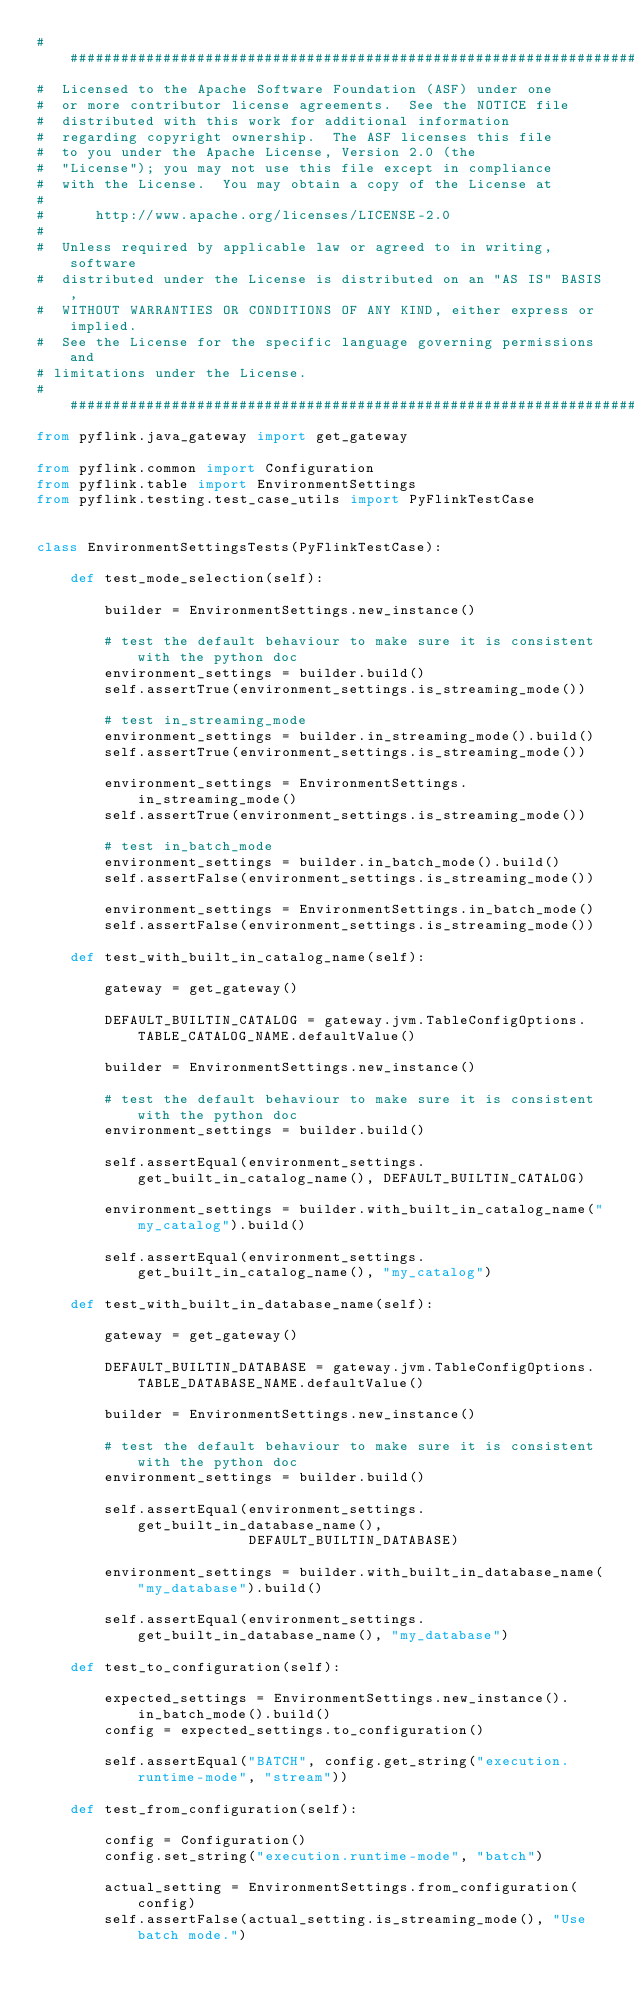<code> <loc_0><loc_0><loc_500><loc_500><_Python_>################################################################################
#  Licensed to the Apache Software Foundation (ASF) under one
#  or more contributor license agreements.  See the NOTICE file
#  distributed with this work for additional information
#  regarding copyright ownership.  The ASF licenses this file
#  to you under the Apache License, Version 2.0 (the
#  "License"); you may not use this file except in compliance
#  with the License.  You may obtain a copy of the License at
#
#      http://www.apache.org/licenses/LICENSE-2.0
#
#  Unless required by applicable law or agreed to in writing, software
#  distributed under the License is distributed on an "AS IS" BASIS,
#  WITHOUT WARRANTIES OR CONDITIONS OF ANY KIND, either express or implied.
#  See the License for the specific language governing permissions and
# limitations under the License.
################################################################################
from pyflink.java_gateway import get_gateway

from pyflink.common import Configuration
from pyflink.table import EnvironmentSettings
from pyflink.testing.test_case_utils import PyFlinkTestCase


class EnvironmentSettingsTests(PyFlinkTestCase):

    def test_mode_selection(self):

        builder = EnvironmentSettings.new_instance()

        # test the default behaviour to make sure it is consistent with the python doc
        environment_settings = builder.build()
        self.assertTrue(environment_settings.is_streaming_mode())

        # test in_streaming_mode
        environment_settings = builder.in_streaming_mode().build()
        self.assertTrue(environment_settings.is_streaming_mode())

        environment_settings = EnvironmentSettings.in_streaming_mode()
        self.assertTrue(environment_settings.is_streaming_mode())

        # test in_batch_mode
        environment_settings = builder.in_batch_mode().build()
        self.assertFalse(environment_settings.is_streaming_mode())

        environment_settings = EnvironmentSettings.in_batch_mode()
        self.assertFalse(environment_settings.is_streaming_mode())

    def test_with_built_in_catalog_name(self):

        gateway = get_gateway()

        DEFAULT_BUILTIN_CATALOG = gateway.jvm.TableConfigOptions.TABLE_CATALOG_NAME.defaultValue()

        builder = EnvironmentSettings.new_instance()

        # test the default behaviour to make sure it is consistent with the python doc
        environment_settings = builder.build()

        self.assertEqual(environment_settings.get_built_in_catalog_name(), DEFAULT_BUILTIN_CATALOG)

        environment_settings = builder.with_built_in_catalog_name("my_catalog").build()

        self.assertEqual(environment_settings.get_built_in_catalog_name(), "my_catalog")

    def test_with_built_in_database_name(self):

        gateway = get_gateway()

        DEFAULT_BUILTIN_DATABASE = gateway.jvm.TableConfigOptions.TABLE_DATABASE_NAME.defaultValue()

        builder = EnvironmentSettings.new_instance()

        # test the default behaviour to make sure it is consistent with the python doc
        environment_settings = builder.build()

        self.assertEqual(environment_settings.get_built_in_database_name(),
                         DEFAULT_BUILTIN_DATABASE)

        environment_settings = builder.with_built_in_database_name("my_database").build()

        self.assertEqual(environment_settings.get_built_in_database_name(), "my_database")

    def test_to_configuration(self):

        expected_settings = EnvironmentSettings.new_instance().in_batch_mode().build()
        config = expected_settings.to_configuration()

        self.assertEqual("BATCH", config.get_string("execution.runtime-mode", "stream"))

    def test_from_configuration(self):

        config = Configuration()
        config.set_string("execution.runtime-mode", "batch")

        actual_setting = EnvironmentSettings.from_configuration(config)
        self.assertFalse(actual_setting.is_streaming_mode(), "Use batch mode.")
</code> 